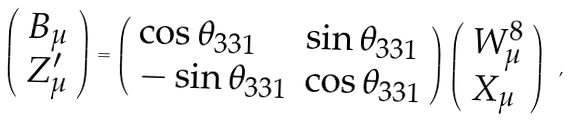<formula> <loc_0><loc_0><loc_500><loc_500>\left ( \begin{array} { l } { { B _ { \mu } } } \\ { { Z _ { \mu } ^ { \prime } } } \end{array} \right ) = \left ( \begin{array} { l l } { { \cos \theta _ { 3 3 1 } } } & { { \sin \theta _ { 3 3 1 } } } \\ { { - \sin \theta _ { 3 3 1 } } } & { { \cos \theta _ { 3 3 1 } } } \end{array} \right ) \left ( \begin{array} { l } { { W _ { \mu } ^ { 8 } } } \\ { { X _ { \mu } } } \end{array} \right ) \ ,</formula> 